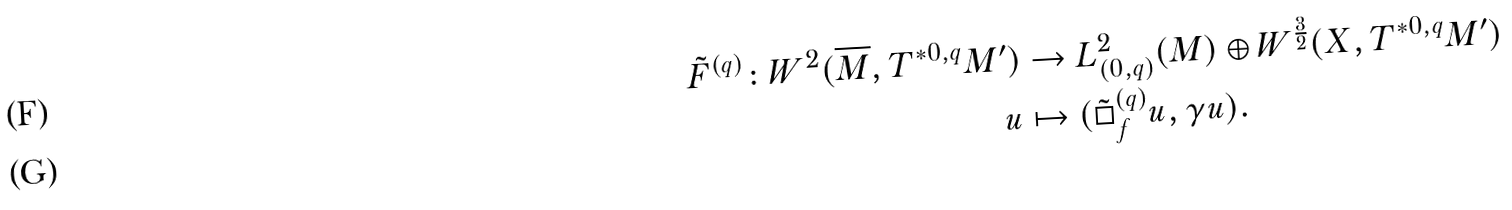<formula> <loc_0><loc_0><loc_500><loc_500>\tilde { F } ^ { ( q ) } \colon W ^ { 2 } ( \overline { M } , T ^ { * 0 , q } M ^ { \prime } ) & \rightarrow L ^ { 2 } _ { ( 0 , q ) } ( M ) \oplus W ^ { \frac { 3 } { 2 } } ( X , T ^ { * 0 , q } M ^ { \prime } ) \\ u & \mapsto ( \tilde { \Box } _ { f } ^ { ( q ) } u , \gamma u ) .</formula> 